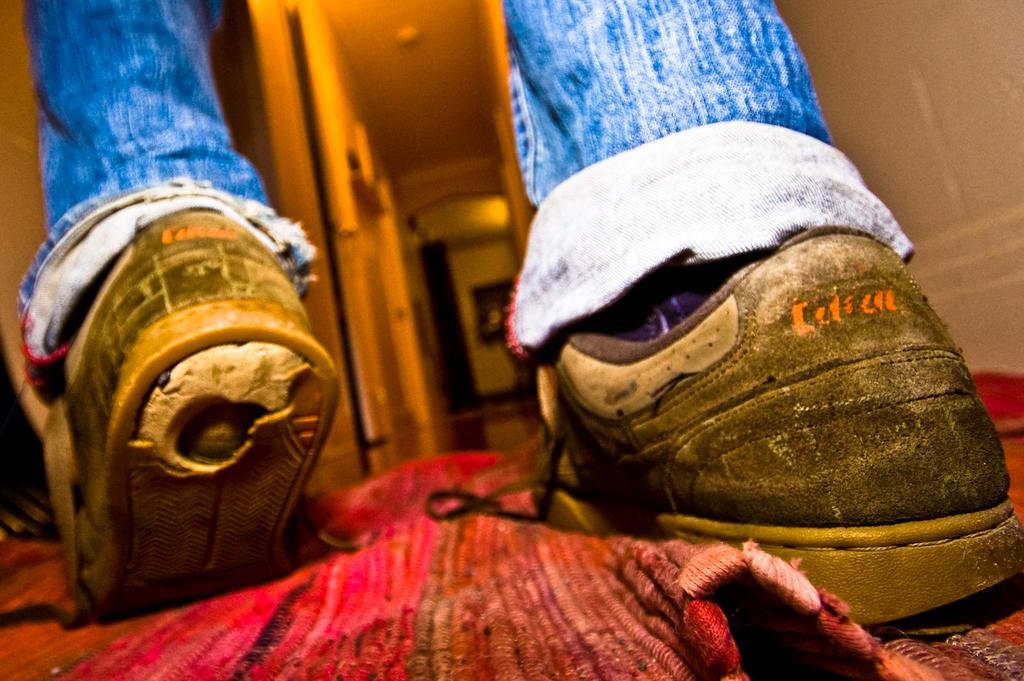In one or two sentences, can you explain what this image depicts? In the picture I can see the legs of a person wearing shoes. I can see the carpet on the floor at the bottom of the picture. 